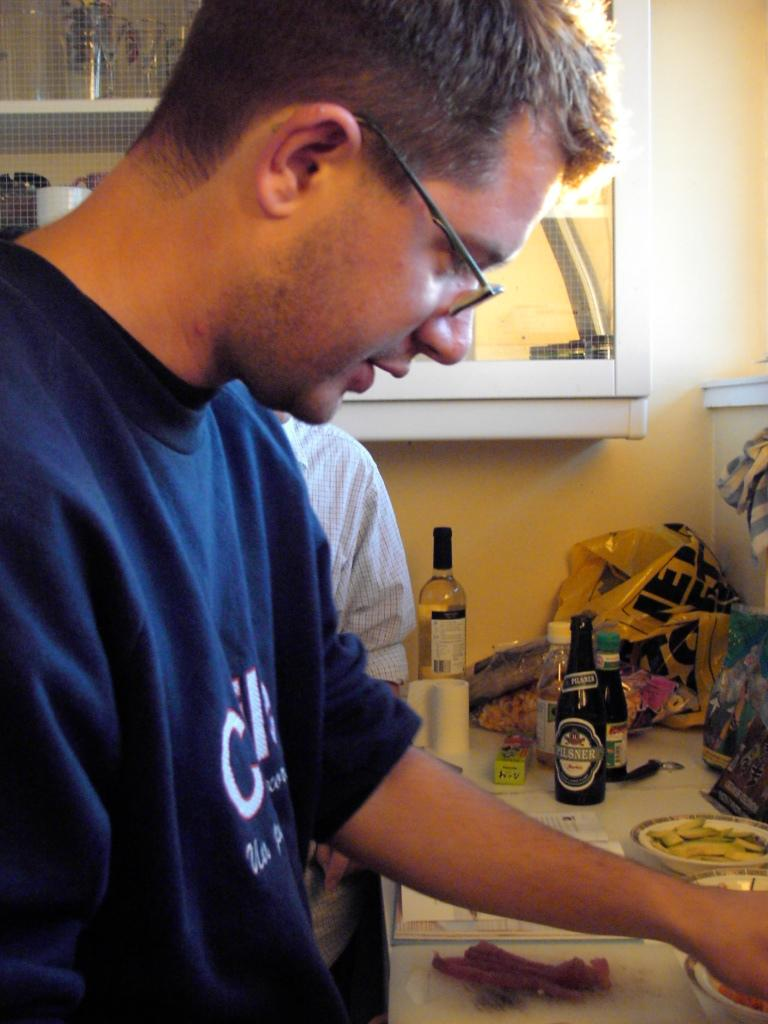What is the main subject of the image? There is a man standing in the image. Can you describe the scene around the man? There is another man standing nearby, and there are bottles visible in the image. What else can be seen in the image? There is a carry bag and bowls on a table in the image. Are there any other objects related to the bottles? Yes, there is a shelf with bottles in the image. What type of truck is parked next to the man in the image? There is no truck present in the image; it only features a man standing, another man nearby, bottles, a carry bag, bowls on a table, and a shelf with bottles. 